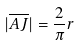<formula> <loc_0><loc_0><loc_500><loc_500>| \overline { A J } | = \frac { 2 } { \pi } r</formula> 